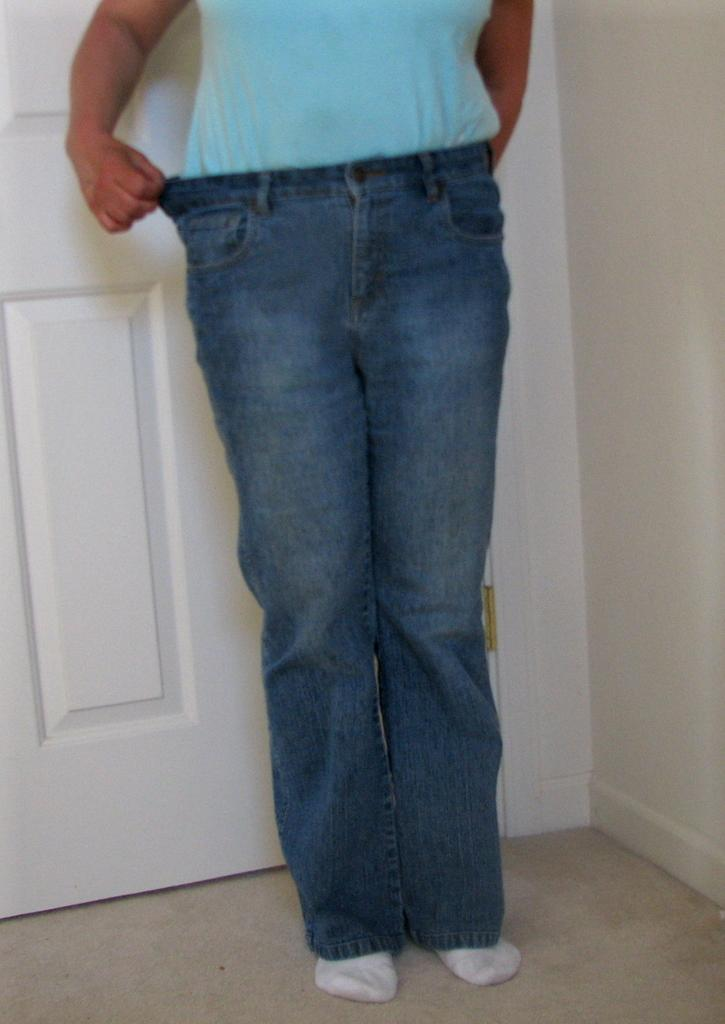Who or what is present in the image? There is a person in the image. What is the person wearing? The person is wearing clothes. Where is the person standing in relation to the door? The person is standing in front of a door. What can be seen on the right side of the image? There is a wall on the right side of the image. How many cars are parked in front of the door in the image? There are no cars present in the image; it only shows a person standing in front of a door with a wall on the right side. 